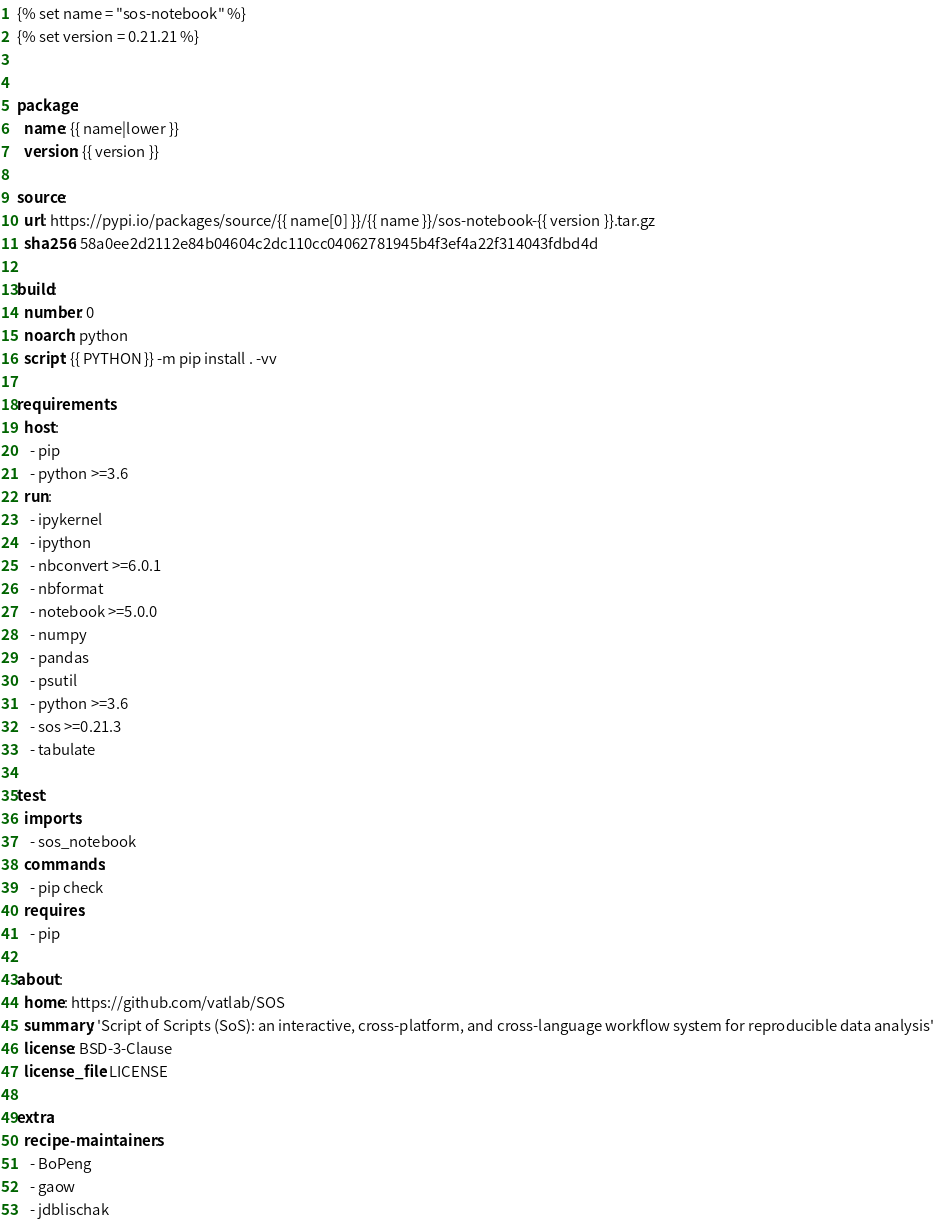<code> <loc_0><loc_0><loc_500><loc_500><_YAML_>{% set name = "sos-notebook" %}
{% set version = 0.21.21 %}


package:
  name: {{ name|lower }}
  version: {{ version }}

source:
  url: https://pypi.io/packages/source/{{ name[0] }}/{{ name }}/sos-notebook-{{ version }}.tar.gz
  sha256: 58a0ee2d2112e84b04604c2dc110cc04062781945b4f3ef4a22f314043fdbd4d

build:
  number: 0
  noarch: python
  script: {{ PYTHON }} -m pip install . -vv

requirements:
  host:
    - pip
    - python >=3.6
  run:
    - ipykernel
    - ipython
    - nbconvert >=6.0.1
    - nbformat
    - notebook >=5.0.0
    - numpy
    - pandas
    - psutil
    - python >=3.6
    - sos >=0.21.3
    - tabulate

test:
  imports:
    - sos_notebook
  commands:
    - pip check
  requires:
    - pip

about:
  home: https://github.com/vatlab/SOS
  summary: 'Script of Scripts (SoS): an interactive, cross-platform, and cross-language workflow system for reproducible data analysis'
  license: BSD-3-Clause
  license_file: LICENSE

extra:
  recipe-maintainers:
    - BoPeng
    - gaow
    - jdblischak
</code> 